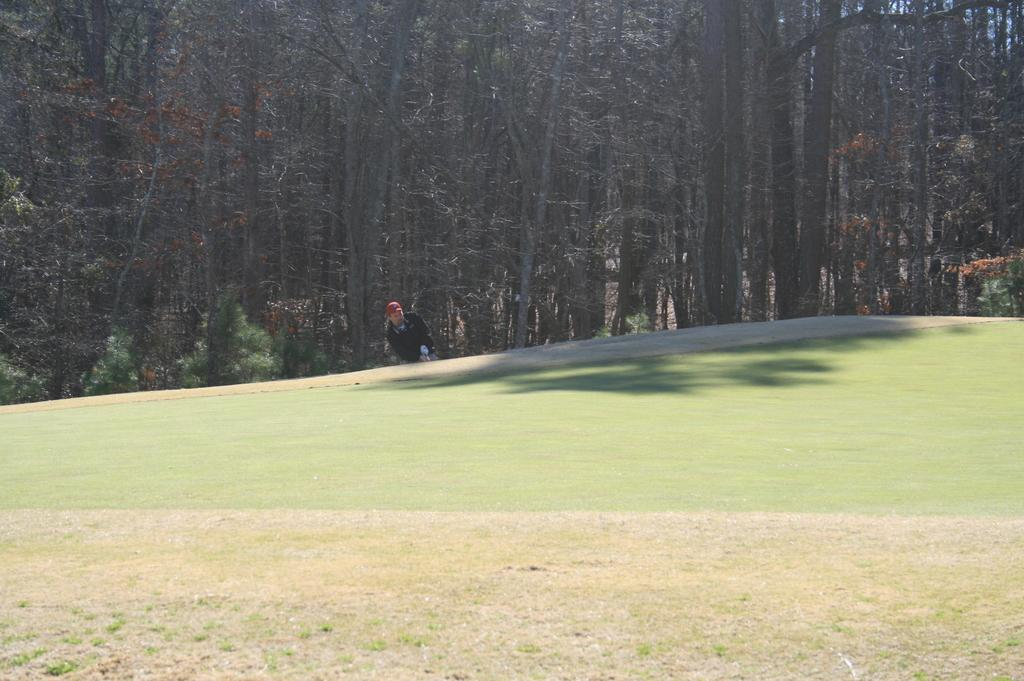Who or what is at the bottom of the image? There is a person at the bottom of the image. What is the person standing or sitting on? The person is on the grass. What can be seen in the background of the image? There are trees in the background of the image. How many ducks are swimming in the ocean in the image? There is no ocean or ducks present in the image. 